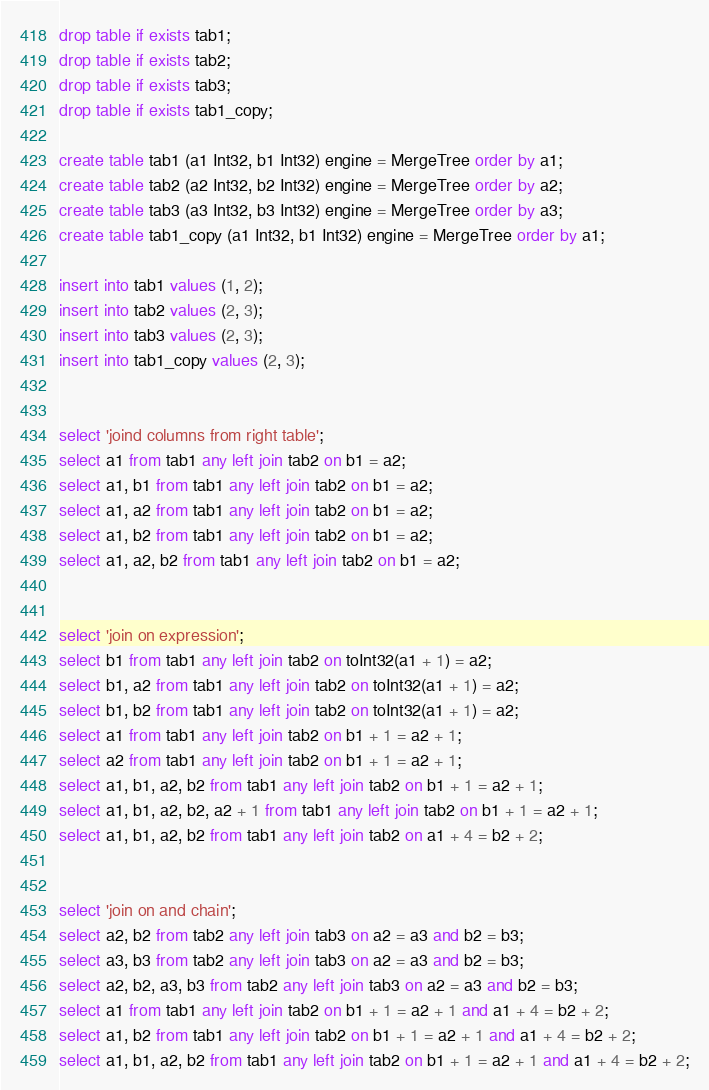Convert code to text. <code><loc_0><loc_0><loc_500><loc_500><_SQL_>drop table if exists tab1;
drop table if exists tab2;
drop table if exists tab3;
drop table if exists tab1_copy;

create table tab1 (a1 Int32, b1 Int32) engine = MergeTree order by a1;
create table tab2 (a2 Int32, b2 Int32) engine = MergeTree order by a2;
create table tab3 (a3 Int32, b3 Int32) engine = MergeTree order by a3;
create table tab1_copy (a1 Int32, b1 Int32) engine = MergeTree order by a1;

insert into tab1 values (1, 2);
insert into tab2 values (2, 3);
insert into tab3 values (2, 3);
insert into tab1_copy values (2, 3);


select 'joind columns from right table';
select a1 from tab1 any left join tab2 on b1 = a2;
select a1, b1 from tab1 any left join tab2 on b1 = a2;
select a1, a2 from tab1 any left join tab2 on b1 = a2;
select a1, b2 from tab1 any left join tab2 on b1 = a2;
select a1, a2, b2 from tab1 any left join tab2 on b1 = a2;


select 'join on expression';
select b1 from tab1 any left join tab2 on toInt32(a1 + 1) = a2;
select b1, a2 from tab1 any left join tab2 on toInt32(a1 + 1) = a2;
select b1, b2 from tab1 any left join tab2 on toInt32(a1 + 1) = a2;
select a1 from tab1 any left join tab2 on b1 + 1 = a2 + 1;
select a2 from tab1 any left join tab2 on b1 + 1 = a2 + 1;
select a1, b1, a2, b2 from tab1 any left join tab2 on b1 + 1 = a2 + 1;
select a1, b1, a2, b2, a2 + 1 from tab1 any left join tab2 on b1 + 1 = a2 + 1;
select a1, b1, a2, b2 from tab1 any left join tab2 on a1 + 4 = b2 + 2;


select 'join on and chain';
select a2, b2 from tab2 any left join tab3 on a2 = a3 and b2 = b3;
select a3, b3 from tab2 any left join tab3 on a2 = a3 and b2 = b3;
select a2, b2, a3, b3 from tab2 any left join tab3 on a2 = a3 and b2 = b3;
select a1 from tab1 any left join tab2 on b1 + 1 = a2 + 1 and a1 + 4 = b2 + 2;
select a1, b2 from tab1 any left join tab2 on b1 + 1 = a2 + 1 and a1 + 4 = b2 + 2;
select a1, b1, a2, b2 from tab1 any left join tab2 on b1 + 1 = a2 + 1 and a1 + 4 = b2 + 2;</code> 